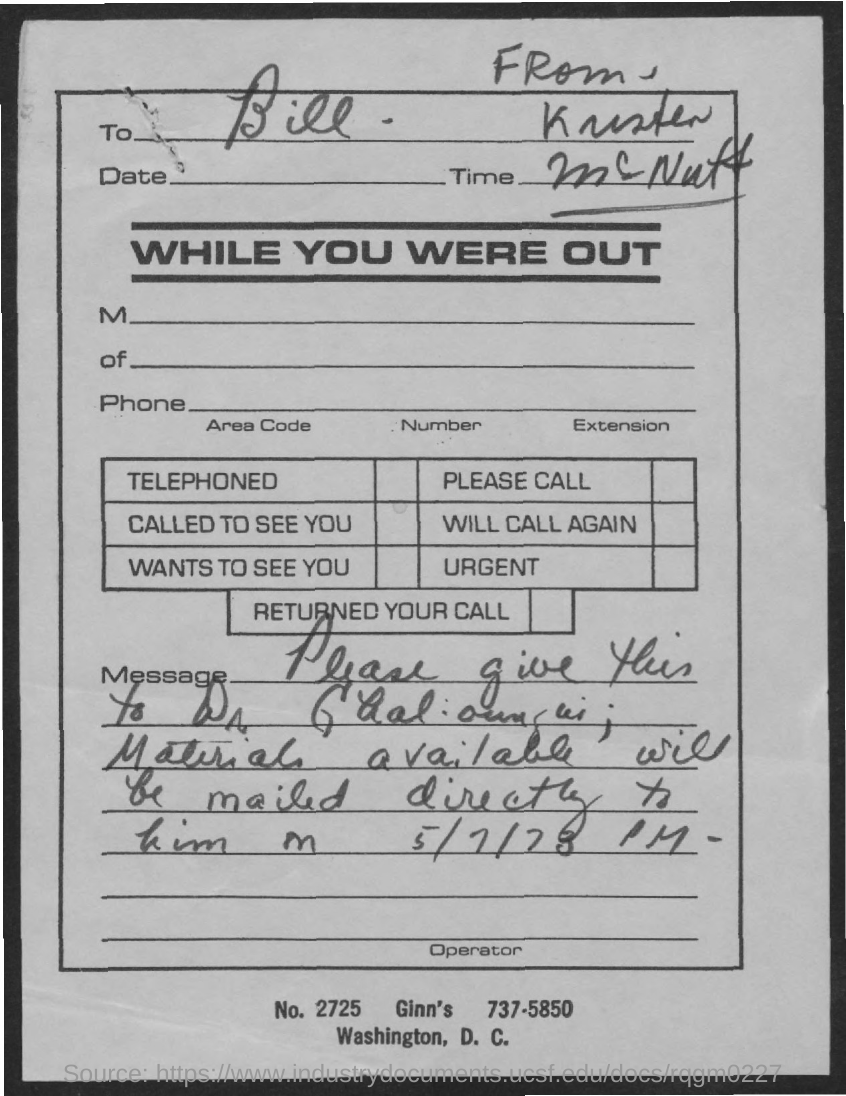The letter is addressed to which person?
Provide a succinct answer. Bill. 